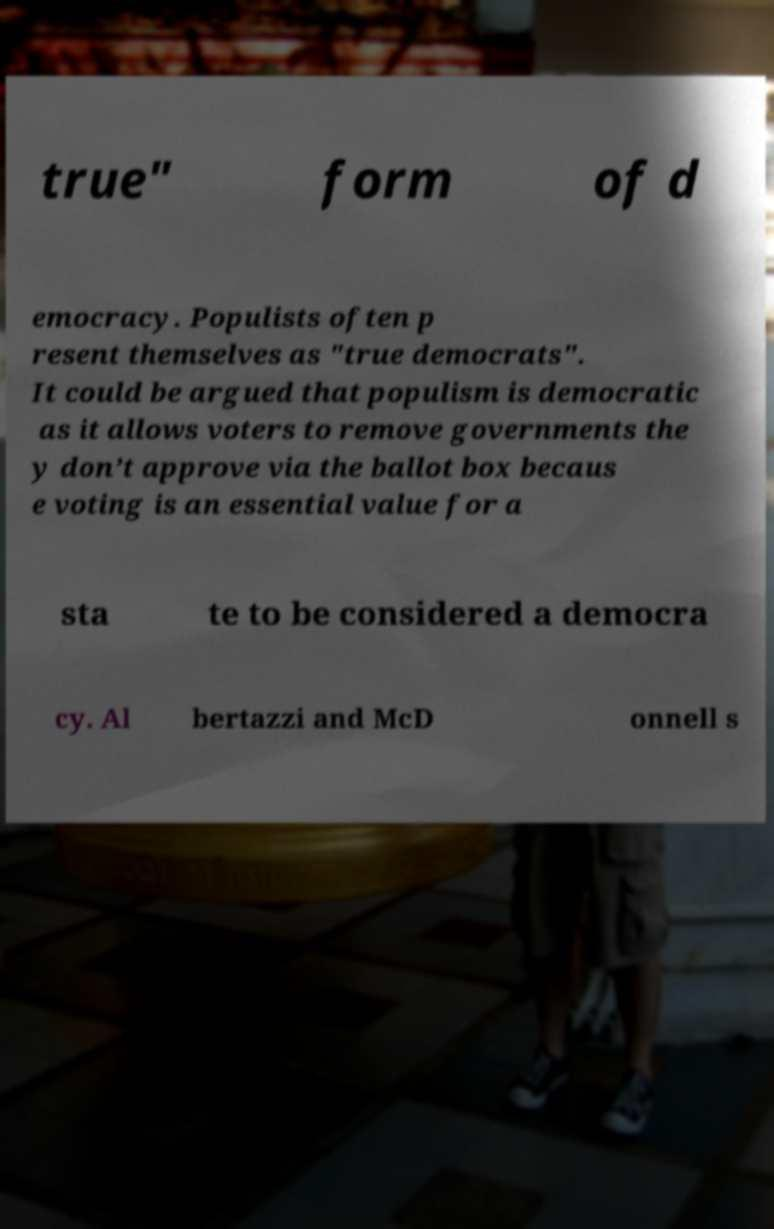Could you assist in decoding the text presented in this image and type it out clearly? true" form of d emocracy. Populists often p resent themselves as "true democrats". It could be argued that populism is democratic as it allows voters to remove governments the y don’t approve via the ballot box becaus e voting is an essential value for a sta te to be considered a democra cy. Al bertazzi and McD onnell s 